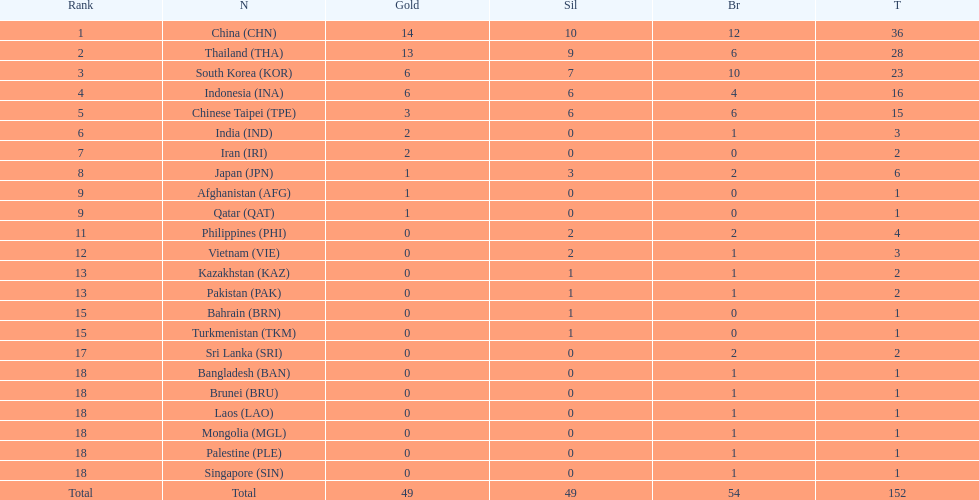What was the number of medals earned by indonesia (ina) ? 16. 